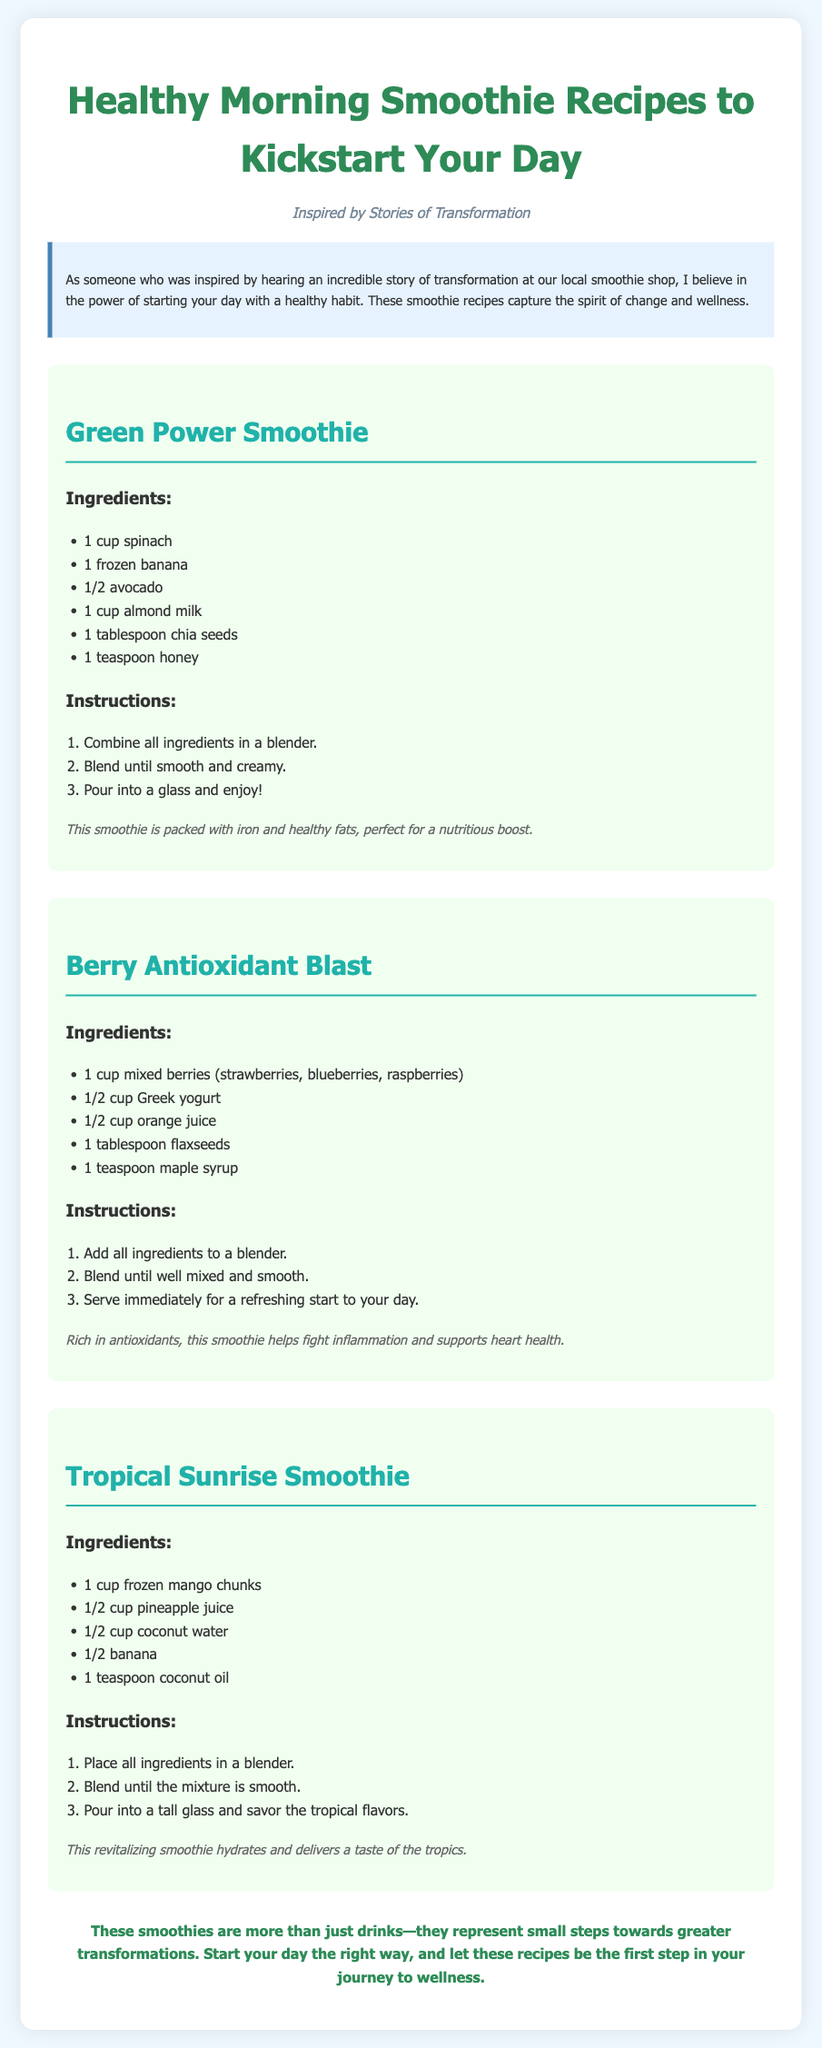What is the title of the document? The title of the document is prominently displayed at the top of the page.
Answer: Healthy Morning Smoothie Recipes How many smoothie recipes are provided? There are several sections for smoothie recipes, specifically counting them can reveal the number.
Answer: Three What ingredient is common in all the recipes? By examining the ingredients lists of each recipe, we can deduce a common ingredient.
Answer: Banana What is the main theme of the document? The theme can be extracted from the subtitle and the introductory paragraph that outlines the purpose of the document.
Answer: Transformation Which smoothie contains Greek yogurt? By checking the ingredients of each recipe, we can see where Greek yogurt is mentioned.
Answer: Berry Antioxidant Blast What is the first step in making the Green Power Smoothie? The instructions for the smoothies outline the procedure step by step.
Answer: Combine all ingredients in a blender What health benefit does the Berry Antioxidant Blast provide? This is mentioned in the note section of the recipe, summarizing its advantages.
Answer: Fights inflammation What liquid is used in the Tropical Sunrise Smoothie? The ingredients list specifies the liquids used in this recipe.
Answer: Coconut water What is the suggested serving method for smoothies? The instructions provide guidance on how to serve the finished smoothies.
Answer: Pour into a glass and enjoy 